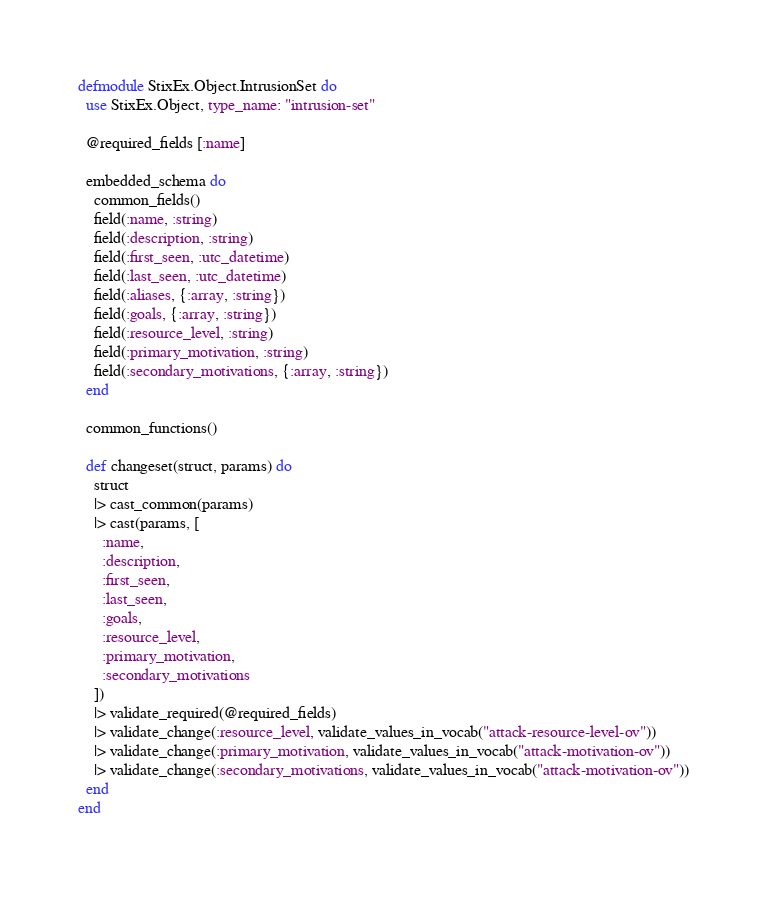<code> <loc_0><loc_0><loc_500><loc_500><_Elixir_>defmodule StixEx.Object.IntrusionSet do
  use StixEx.Object, type_name: "intrusion-set"

  @required_fields [:name]

  embedded_schema do
    common_fields()
    field(:name, :string)
    field(:description, :string)
    field(:first_seen, :utc_datetime)
    field(:last_seen, :utc_datetime)
    field(:aliases, {:array, :string})
    field(:goals, {:array, :string})
    field(:resource_level, :string)
    field(:primary_motivation, :string)
    field(:secondary_motivations, {:array, :string})
  end

  common_functions()

  def changeset(struct, params) do
    struct
    |> cast_common(params)
    |> cast(params, [
      :name,
      :description,
      :first_seen,
      :last_seen,
      :goals,
      :resource_level,
      :primary_motivation,
      :secondary_motivations
    ])
    |> validate_required(@required_fields)
    |> validate_change(:resource_level, validate_values_in_vocab("attack-resource-level-ov"))
    |> validate_change(:primary_motivation, validate_values_in_vocab("attack-motivation-ov"))
    |> validate_change(:secondary_motivations, validate_values_in_vocab("attack-motivation-ov"))
  end
end
</code> 